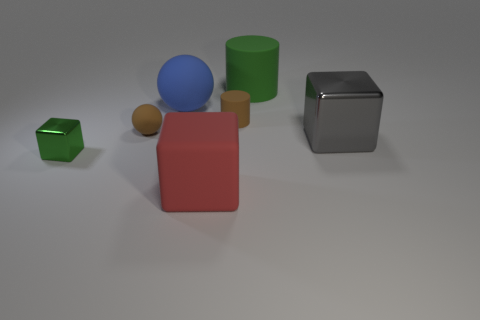There is a matte thing that is the same color as the tiny cube; what is its shape?
Provide a short and direct response. Cylinder. What size is the object that is the same color as the tiny metallic block?
Provide a succinct answer. Large. Does the tiny cylinder have the same color as the tiny rubber thing that is in front of the small matte cylinder?
Make the answer very short. Yes. There is a small thing that is left of the tiny brown cylinder and to the right of the tiny metal block; what color is it?
Ensure brevity in your answer.  Brown. There is a red matte object; is it the same size as the metal object that is to the right of the big green rubber object?
Give a very brief answer. Yes. What is the shape of the brown object on the left side of the tiny brown rubber cylinder?
Offer a very short reply. Sphere. Is the number of shiny blocks to the left of the large rubber sphere greater than the number of tiny purple matte spheres?
Offer a very short reply. Yes. How many cubes are on the right side of the cylinder on the left side of the matte object on the right side of the tiny brown cylinder?
Keep it short and to the point. 1. Is the size of the cylinder in front of the large blue thing the same as the green thing in front of the green matte object?
Ensure brevity in your answer.  Yes. What material is the cube that is right of the cylinder that is in front of the blue rubber sphere made of?
Keep it short and to the point. Metal. 